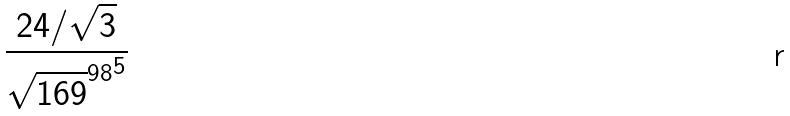Convert formula to latex. <formula><loc_0><loc_0><loc_500><loc_500>\frac { 2 4 / \sqrt { 3 } } { { \sqrt { 1 6 9 } ^ { 9 8 } } ^ { 5 } }</formula> 